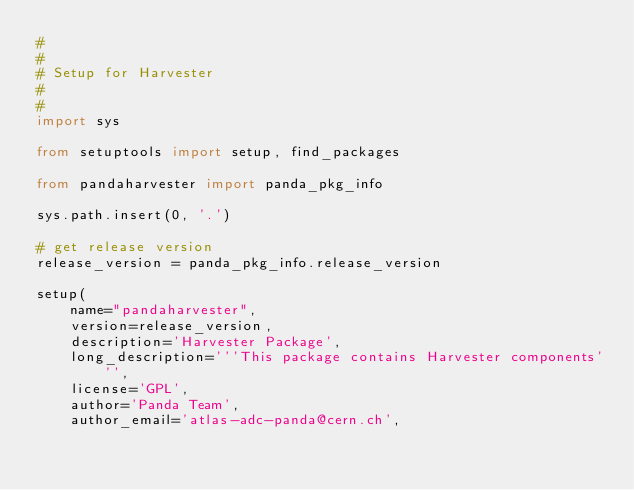<code> <loc_0><loc_0><loc_500><loc_500><_Python_>#
#
# Setup for Harvester
#
#
import sys

from setuptools import setup, find_packages

from pandaharvester import panda_pkg_info

sys.path.insert(0, '.')

# get release version
release_version = panda_pkg_info.release_version

setup(
    name="pandaharvester",
    version=release_version,
    description='Harvester Package',
    long_description='''This package contains Harvester components''',
    license='GPL',
    author='Panda Team',
    author_email='atlas-adc-panda@cern.ch',</code> 